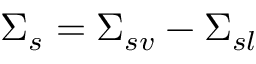<formula> <loc_0><loc_0><loc_500><loc_500>\Sigma _ { s } = \Sigma _ { s v } - \Sigma _ { s l }</formula> 